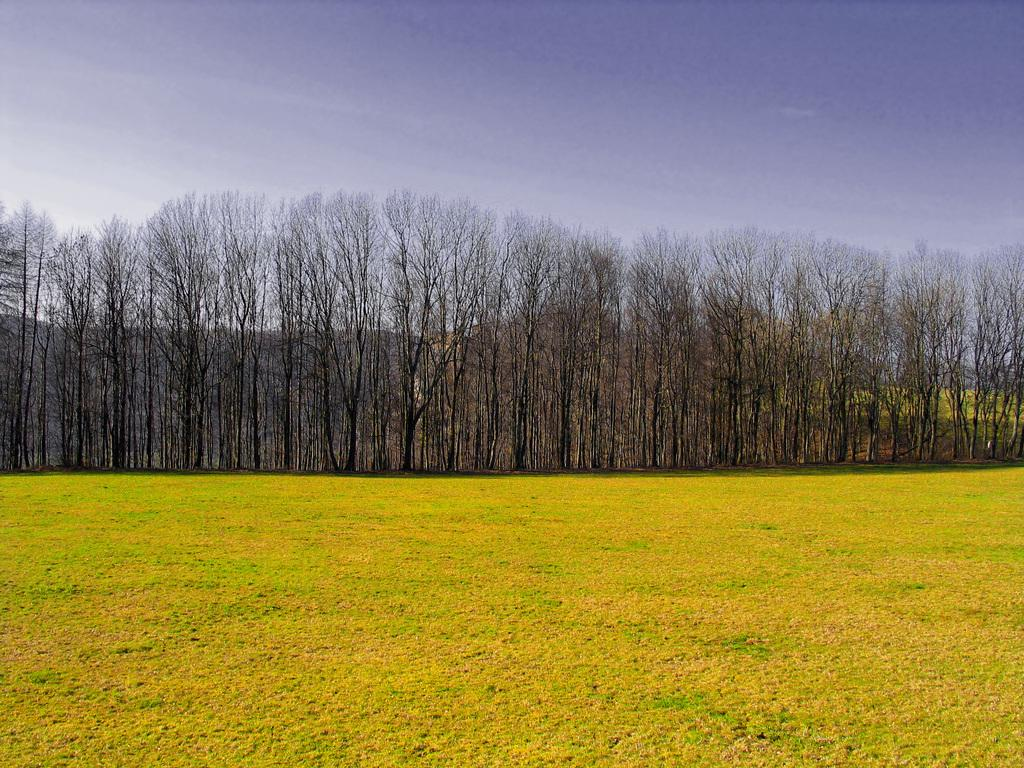What is located in the foreground of the image? There is a field in the foreground of the image. What can be seen in the background of the image? There are trees and mountains in the background of the image. What is visible in the sky in the image? The sky is visible in the background of the image. Can you see a harmony of colors in the image? The term "harmony" is subjective and not directly observable in the image. However, the image does show a combination of colors from the field, trees, mountains, and sky. Is there a lamp visible in the image? There is no lamp present in the image. Are there any pears visible in the image? There are no pears present in the image. 